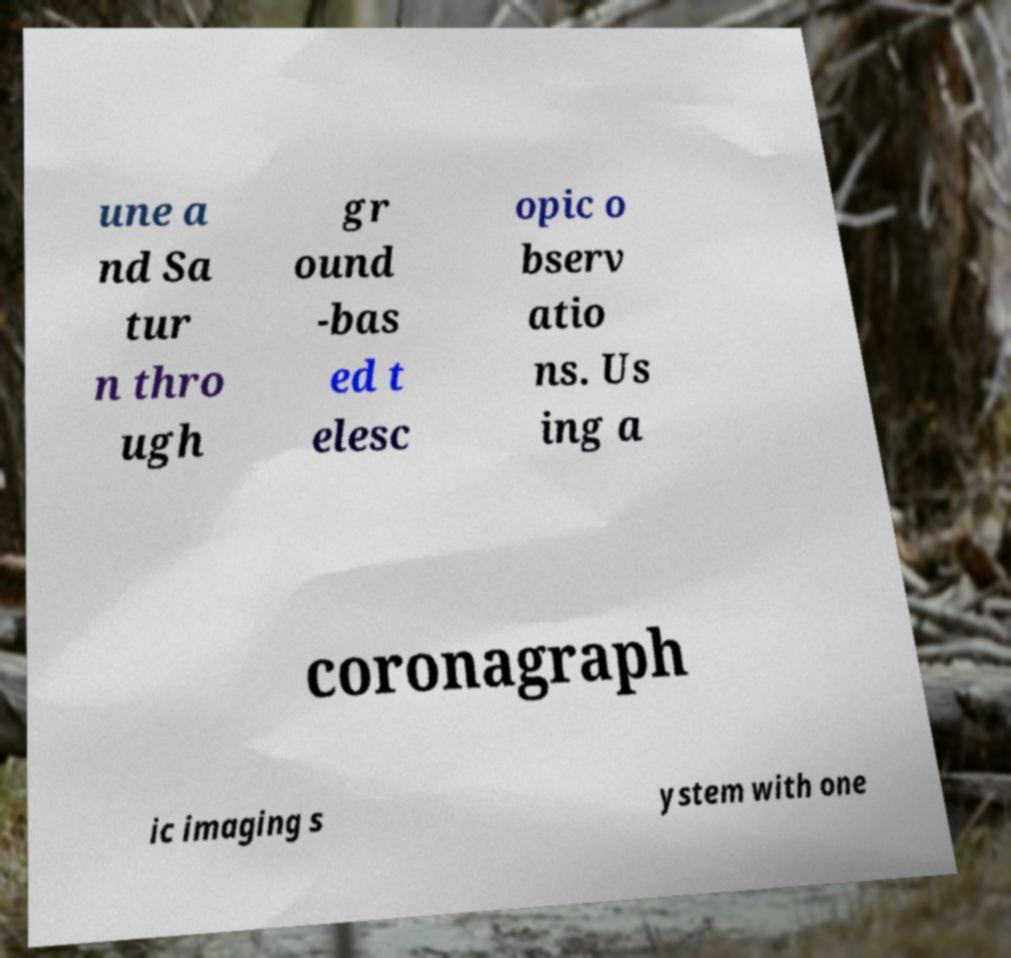Can you accurately transcribe the text from the provided image for me? une a nd Sa tur n thro ugh gr ound -bas ed t elesc opic o bserv atio ns. Us ing a coronagraph ic imaging s ystem with one 